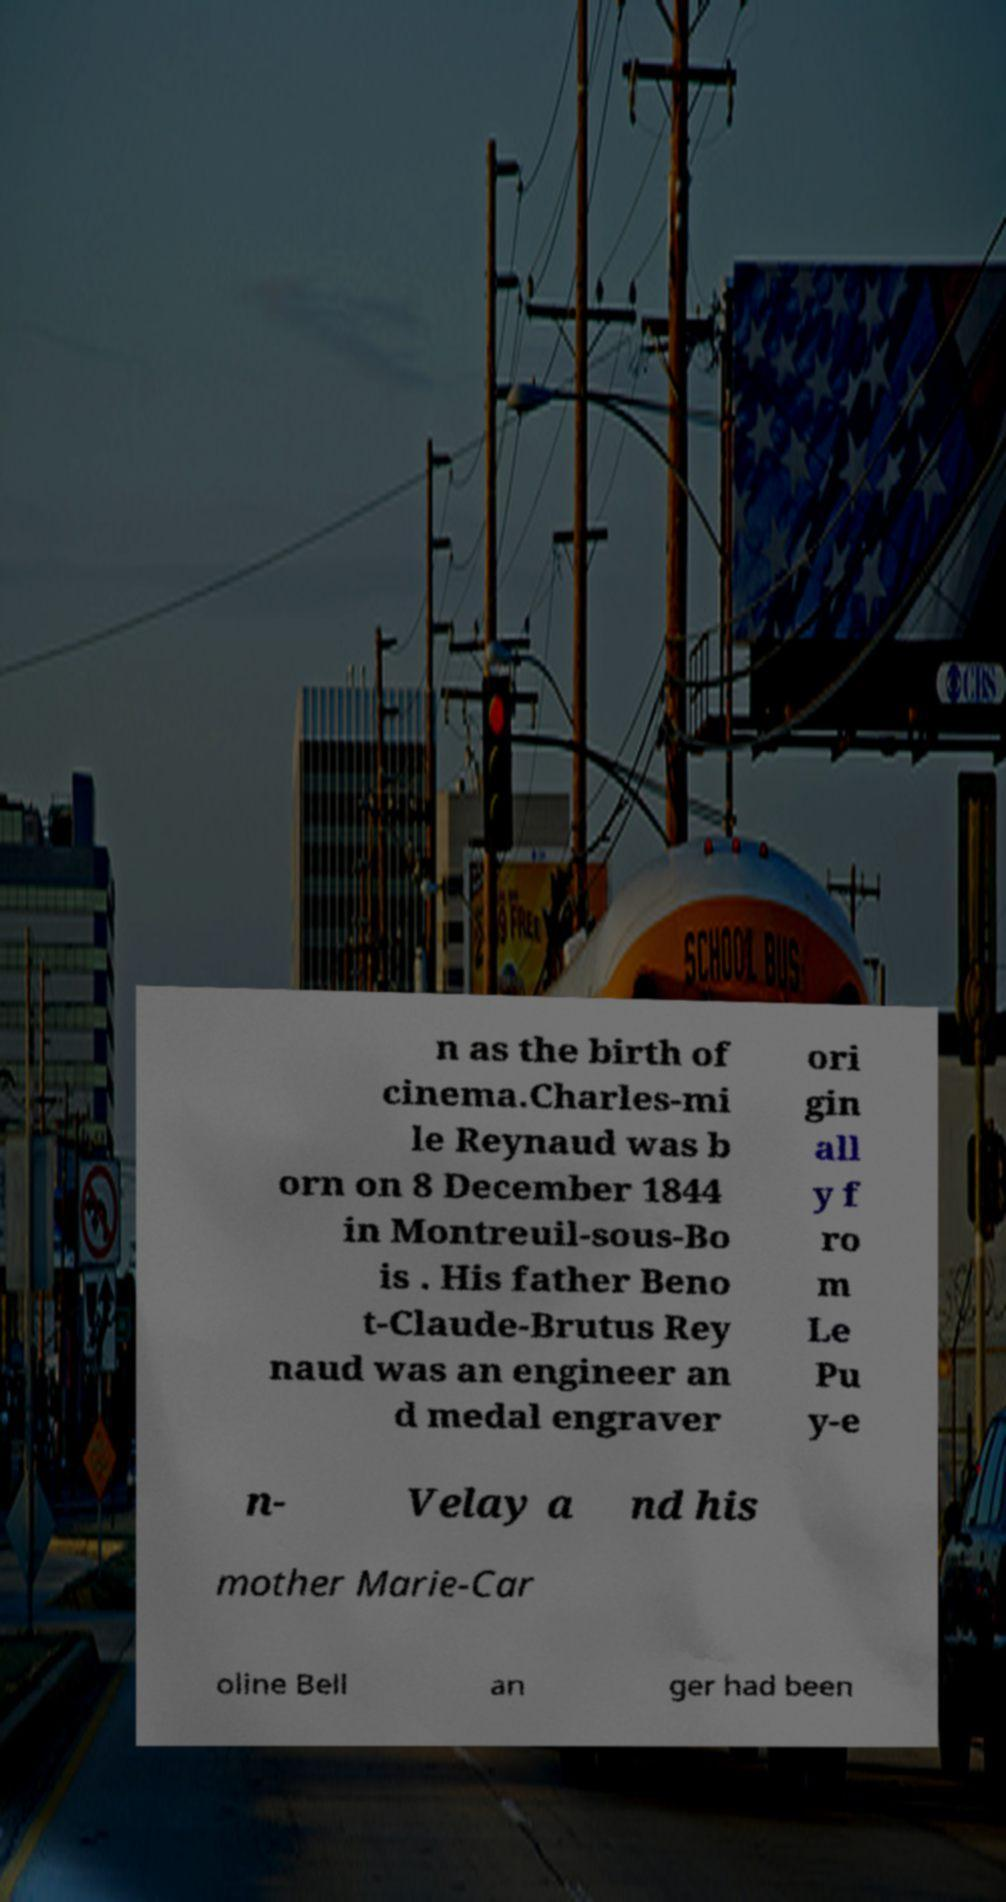What messages or text are displayed in this image? I need them in a readable, typed format. n as the birth of cinema.Charles-mi le Reynaud was b orn on 8 December 1844 in Montreuil-sous-Bo is . His father Beno t-Claude-Brutus Rey naud was an engineer an d medal engraver ori gin all y f ro m Le Pu y-e n- Velay a nd his mother Marie-Car oline Bell an ger had been 